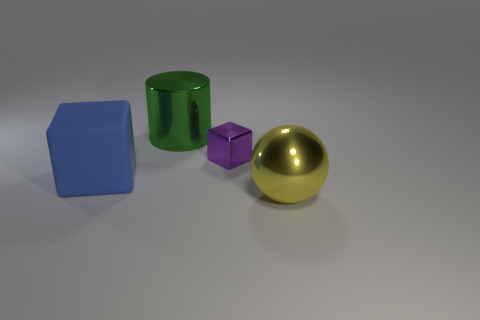Add 1 tiny things. How many objects exist? 5 Subtract all yellow cubes. Subtract all purple cylinders. How many cubes are left? 2 Subtract all cylinders. How many objects are left? 3 Add 1 big yellow spheres. How many big yellow spheres exist? 2 Subtract 0 cyan cylinders. How many objects are left? 4 Subtract all matte things. Subtract all cylinders. How many objects are left? 2 Add 3 big green cylinders. How many big green cylinders are left? 4 